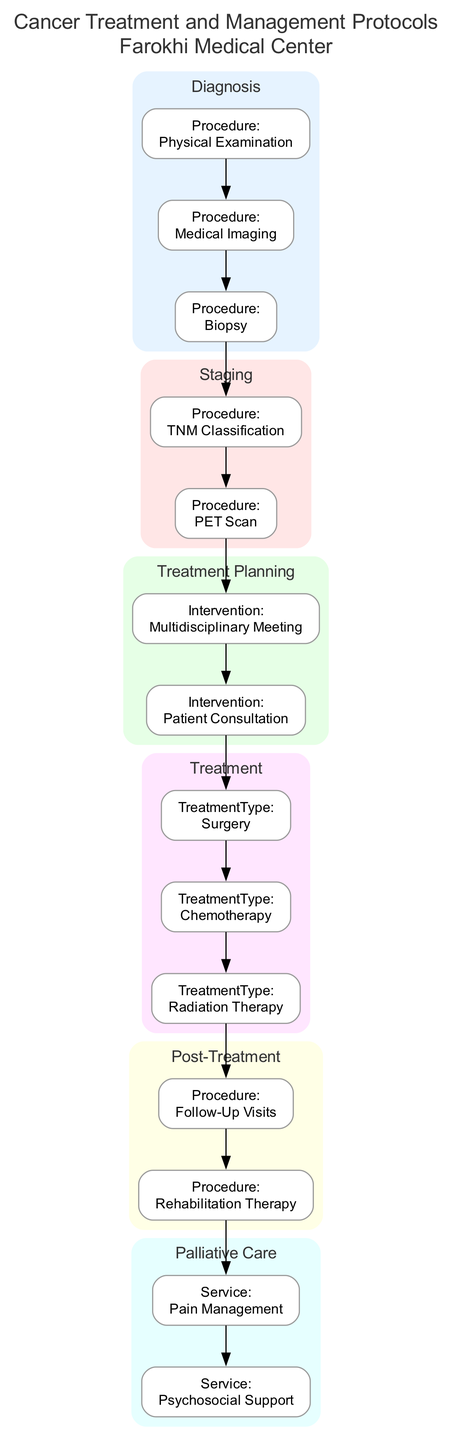What is the first step in the Diagnosis phase? The first step listed under the Diagnosis phase is the "Physical Examination," which involves a general health check-up to identify any potential symptoms.
Answer: Physical Examination How many steps are there in the Staging phase? In the Staging phase, there are two steps: "TNM Classification" and "PET Scan." This can be counted directly from the listing in the diagram.
Answer: 2 What type of interventions occur during the Treatment Planning phase? The interventions listed in the Treatment Planning phase are "Multidisciplinary Meeting" and "Patient Consultation." These interventions focus on collaborative planning and communication with the patient.
Answer: Multidisciplinary Meeting, Patient Consultation Which phase includes "Pain Management" as a service? "Pain Management" is included in the Palliative Care phase, which focuses on providing relief from pain and other symptoms.
Answer: Palliative Care What follows the "Follow-Up Visits" procedure in the Post-Treatment phase? After "Follow-Up Visits," the next step in the Post-Treatment phase is "Rehabilitation Therapy," which aids in the recovery of the patient.
Answer: Rehabilitation Therapy How many total phases are there in the clinical pathway? There are a total of six phases in the clinical pathway, as seen in the diagram: Diagnosis, Staging, Treatment Planning, Treatment, Post-Treatment, and Palliative Care.
Answer: 6 What describes the relationship between the "Treatment" phase and the "Post-Treatment" phase? The "Treatment" phase directly leads to the "Post-Treatment" phase, indicating that treatment must occur before follow-up care and rehabilitation can be addressed.
Answer: Directly leads to Which step comes after "Surgery" in the Treatment phase? The step that comes after "Surgery" is "Chemotherapy" in the Treatment phase, indicating a sequential order of treatments provided.
Answer: Chemotherapy What is the main purpose of the "Rehabilitation Therapy" step? The main purpose of the "Rehabilitation Therapy" step is to aid recovery through physical and occupational therapy, emphasizing support for patient healing.
Answer: Aid recovery 